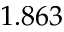<formula> <loc_0><loc_0><loc_500><loc_500>1 . 8 6 3</formula> 